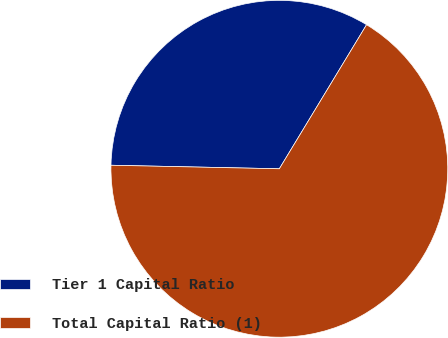Convert chart. <chart><loc_0><loc_0><loc_500><loc_500><pie_chart><fcel>Tier 1 Capital Ratio<fcel>Total Capital Ratio (1)<nl><fcel>33.33%<fcel>66.67%<nl></chart> 